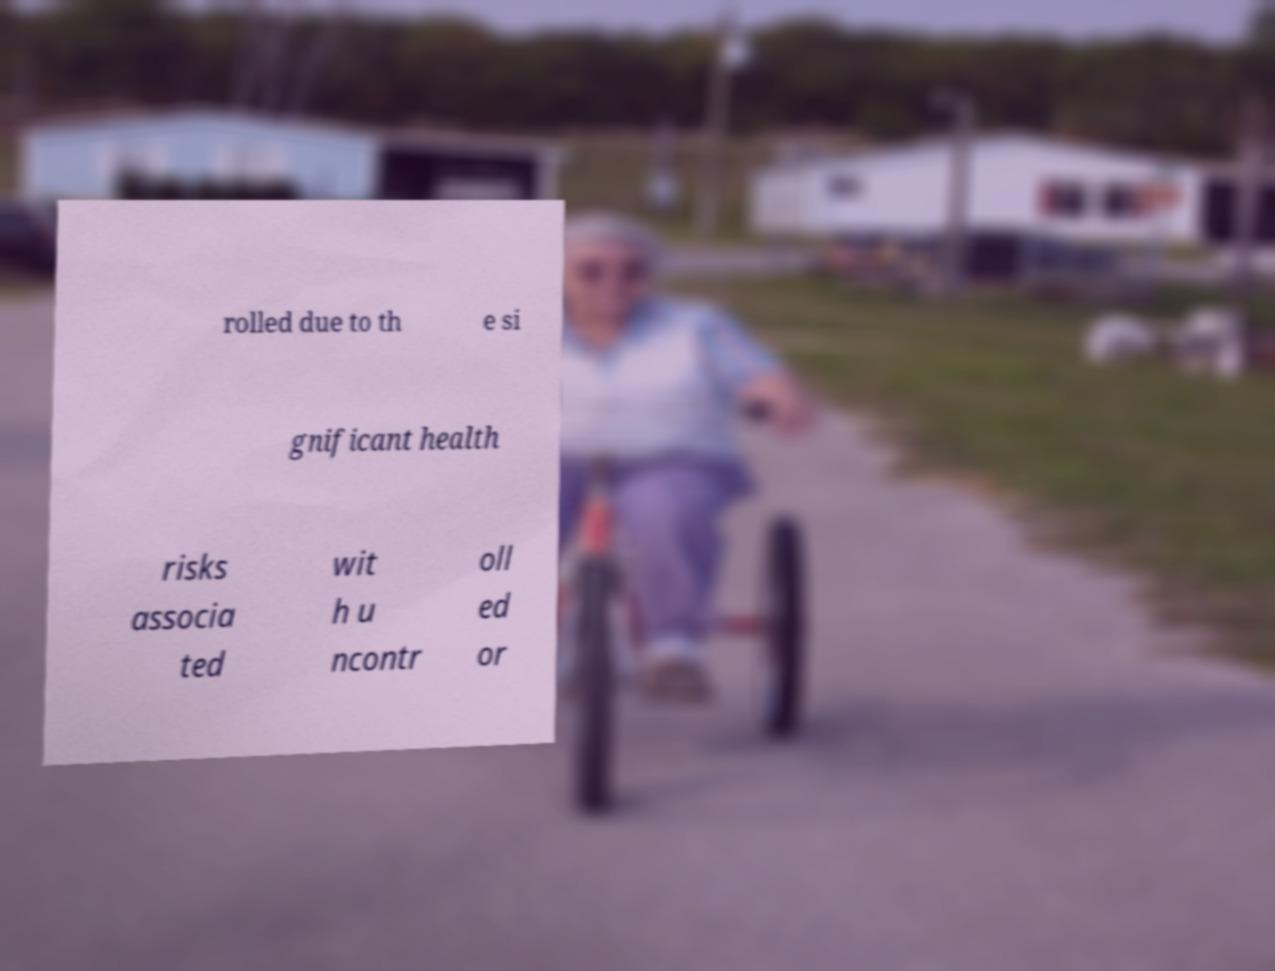Could you extract and type out the text from this image? rolled due to th e si gnificant health risks associa ted wit h u ncontr oll ed or 